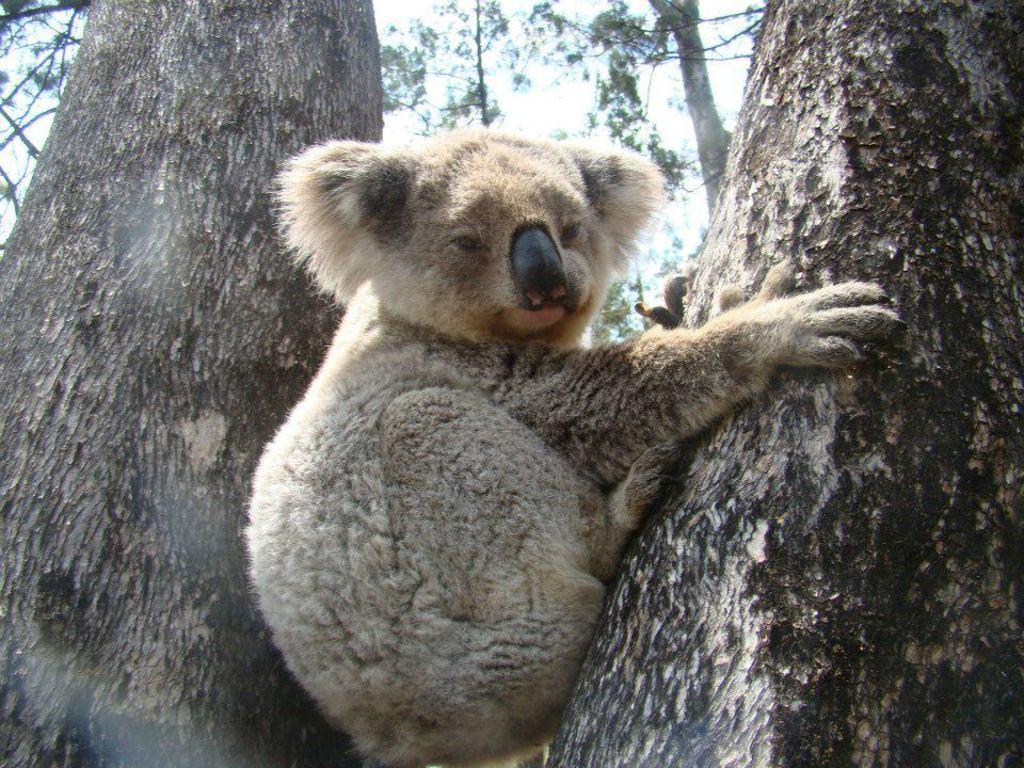What type of animal is present in the image? There is an animal in the image, but its specific type cannot be determined from the provided facts. Where is the animal located in relation to the trees? The animal is between two trees, and it is on the right side tree. What can be seen in the background of the image? There are trees and the sky visible in the background of the image. What sense does the animal use to detect the presence of the trees? The provided facts do not specify which sense the animal uses to detect the presence of the trees. 